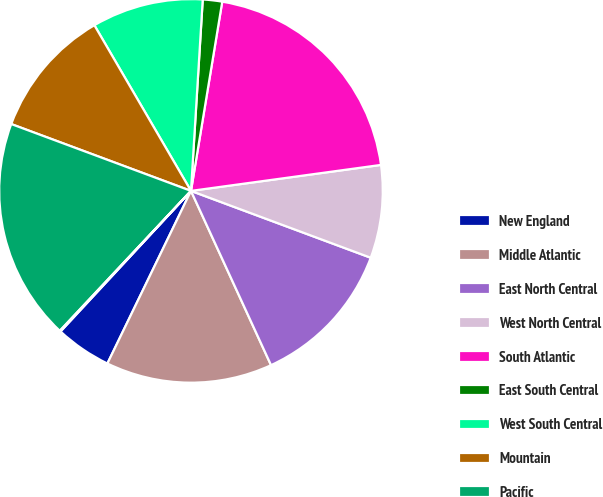Convert chart. <chart><loc_0><loc_0><loc_500><loc_500><pie_chart><fcel>New England<fcel>Middle Atlantic<fcel>East North Central<fcel>West North Central<fcel>South Atlantic<fcel>East South Central<fcel>West South Central<fcel>Mountain<fcel>Pacific<fcel>Valuation allowance<nl><fcel>4.73%<fcel>14.03%<fcel>12.48%<fcel>7.83%<fcel>20.23%<fcel>1.63%<fcel>9.38%<fcel>10.93%<fcel>18.68%<fcel>0.08%<nl></chart> 